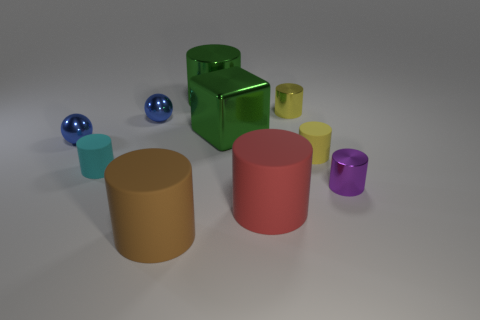Are there any patterns or textures on any of the objects? No, all objects in the image have smooth surfaces without any visible patterns or textures. Their simple, solid colors emphasize the play of light and shadow on their forms.  How does the lighting in the image affect the perception of the objects? The image appears to be lit from above, creating soft shadows beneath the objects. The lighting highlights the shapes and contours of the objects, accentuating their three-dimensionality and the differences in their surface materials. 